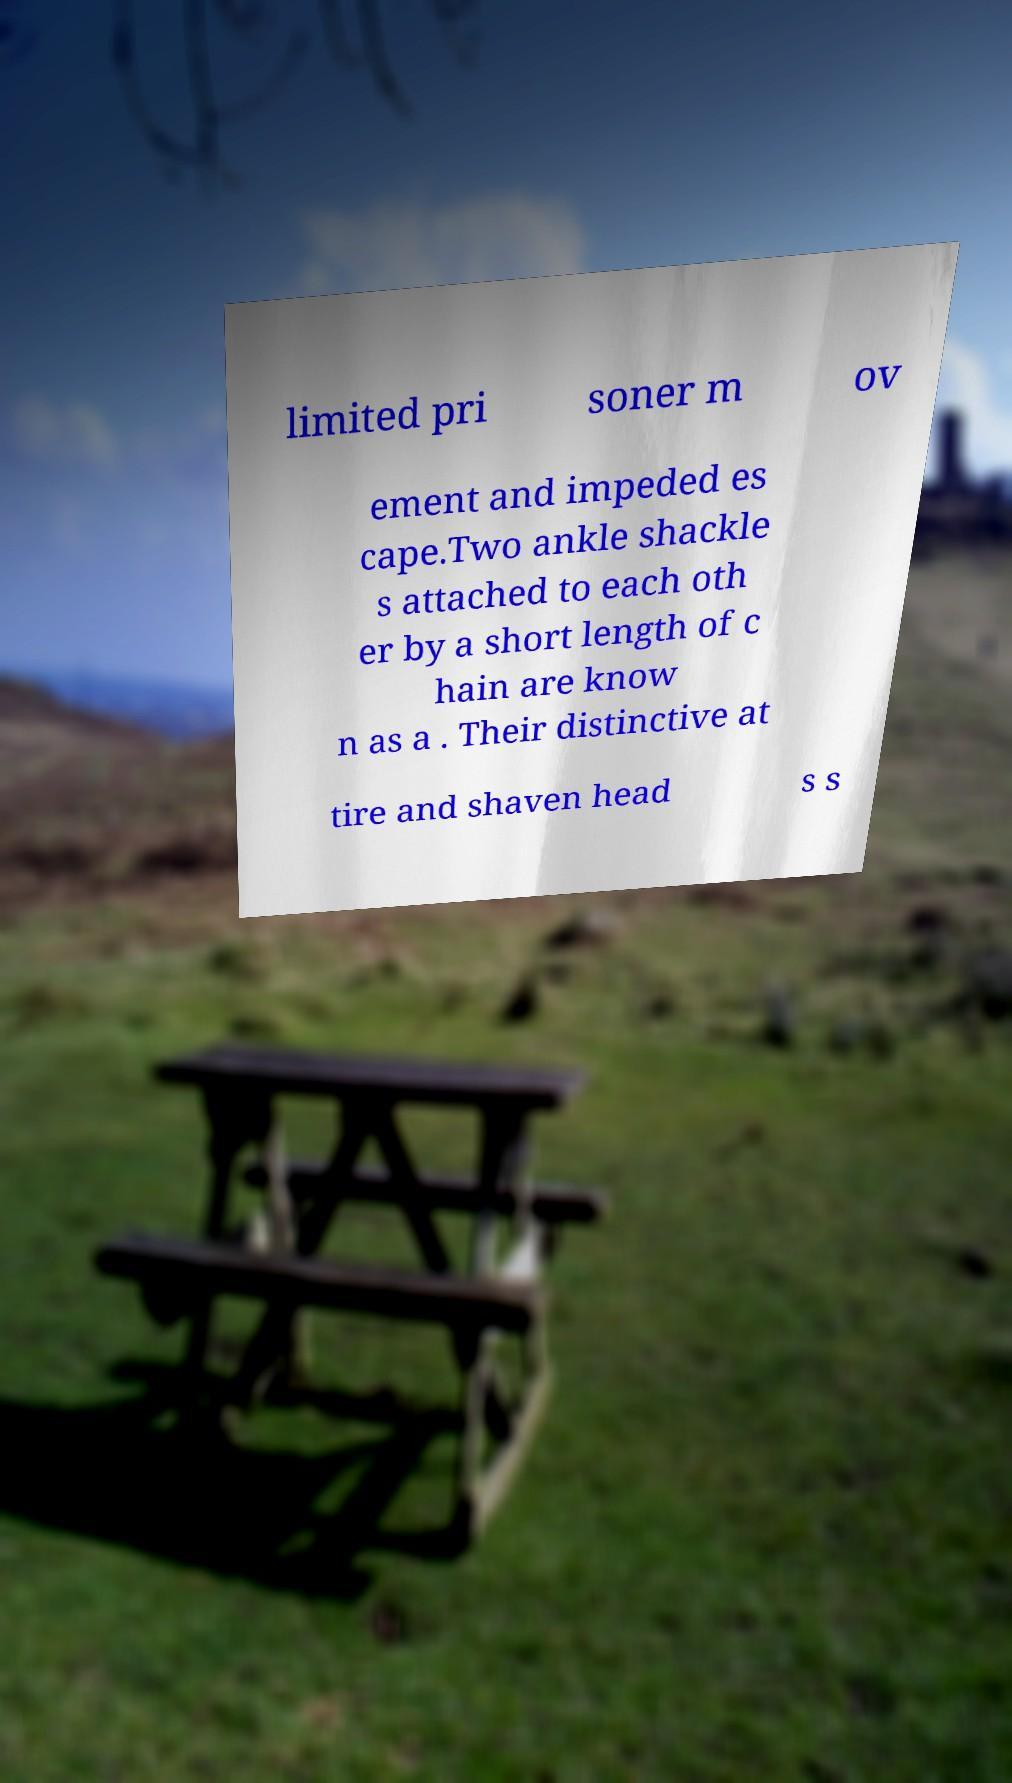Please read and relay the text visible in this image. What does it say? limited pri soner m ov ement and impeded es cape.Two ankle shackle s attached to each oth er by a short length of c hain are know n as a . Their distinctive at tire and shaven head s s 